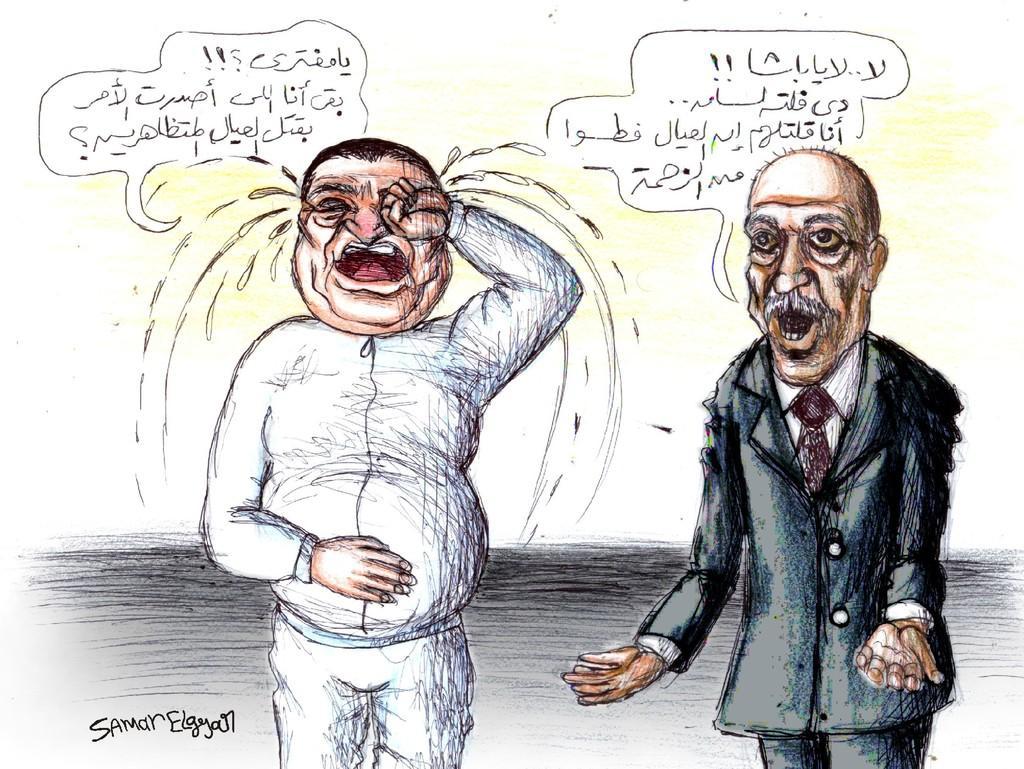Please provide a concise description of this image. In the image there is a comic of an old man in suit on the right side and another man in white dress crying on the left side with some text above it. 